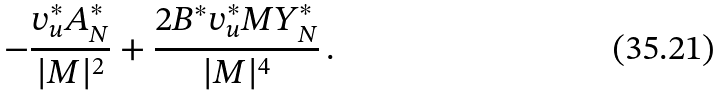Convert formula to latex. <formula><loc_0><loc_0><loc_500><loc_500>- \frac { v _ { u } ^ { * } A _ { N } ^ { * } } { | M | ^ { 2 } } + \frac { 2 B ^ { * } v _ { u } ^ { * } M Y _ { N } ^ { * } } { | M | ^ { 4 } } \, .</formula> 